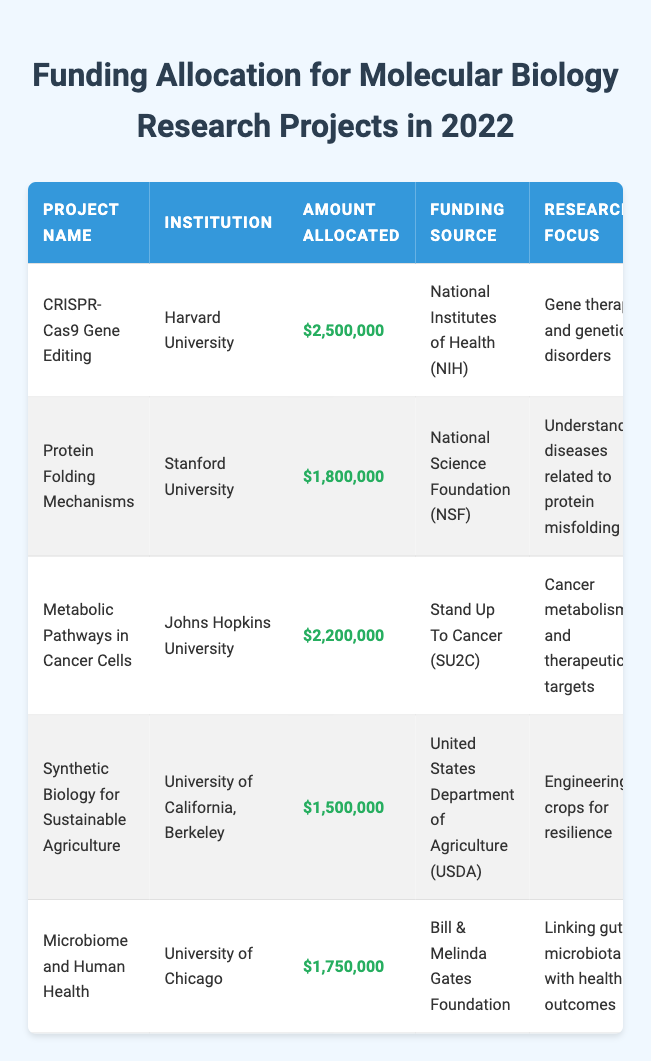What is the total amount allocated for the project "CRISPR-Cas9 Gene Editing"? The amount allocated for "CRISPR-Cas9 Gene Editing" can be found in the table under the column "Amount Allocated" corresponding to that project. It shows $2,500,000.
Answer: $2,500,000 Which institution received funding for the "Microbiome and Human Health" project? The table lists "Microbiome and Human Health" under the "Project Name" column. Referring to the same row in the "Institution" column reveals that it is the University of Chicago.
Answer: University of Chicago Is the funding source for the "Protein Folding Mechanisms" project the National Institutes of Health? To answer this, look at the "Funding Source" column for the row related to "Protein Folding Mechanisms." It is actually from the National Science Foundation, so the statement is not true.
Answer: No What is the duration of the project titled "Metabolic Pathways in Cancer Cells"? The "Duration" column for "Metabolic Pathways in Cancer Cells" is checked. It shows that the project lasts for 4 years.
Answer: 4 years What is the average funding allocation among all listed projects? To find the average, first, sum the amounts allocated. The total is $2,500,000 + $1,800,000 + $2,200,000 + $1,500,000 + $1,750,000 = $10,750,000. Since there are 5 projects, divide the total by 5: $10,750,000 / 5 = $2,150,000.
Answer: $2,150,000 Which project has the highest amount allocated and what is that amount? By comparing the amounts allocated across all projects listed in the table, "CRISPR-Cas9 Gene Editing" has the highest allocation of $2,500,000, making it the highest.
Answer: CRISPR-Cas9 Gene Editing, $2,500,000 How many projects have a duration of 3 years? Review the duration of each project. The projects with 3 years duration are "CRISPR-Cas9 Gene Editing," "Synthetic Biology for Sustainable Agriculture," and "Microbiome and Human Health," giving a total of 3 projects.
Answer: 3 Is the funding source for any of the projects the Bill & Melinda Gates Foundation? Looking through the "Funding Source" column, the project "Microbiome and Human Health" does receive funding from the Bill & Melinda Gates Foundation, confirming this statement is true.
Answer: Yes What percentage of the total funding is allocated to the "Synthetic Biology for Sustainable Agriculture" project? First, the total funding is $10,750,000. The allocated amount for "Synthetic Biology for Sustainable Agriculture" is $1,500,000. The percentage is calculated by ($1,500,000 / $10,750,000) * 100 = approximately 13.95%.
Answer: Approximately 13.95% 